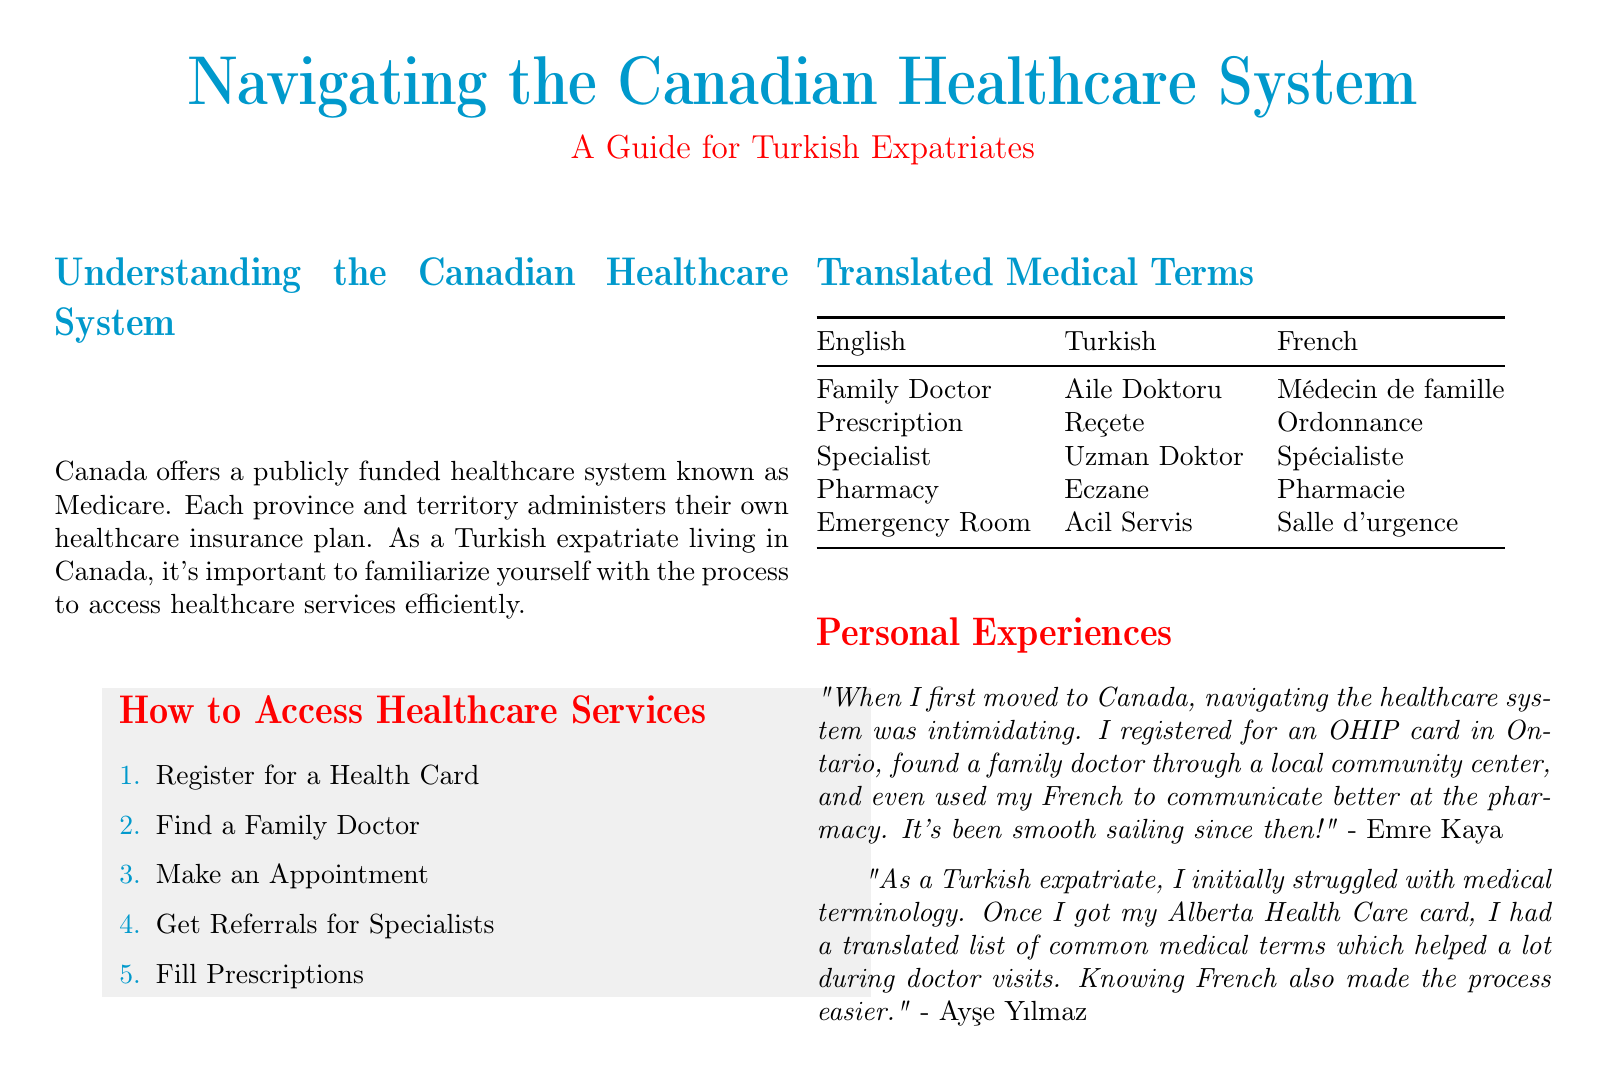What is the title of the document? The title of the document is prominently displayed at the top of the first page.
Answer: Navigating the Canadian Healthcare System Who is the guide primarily intended for? The introduction clearly states the target audience for the guide.
Answer: Turkish Expatriates What is the first step to access healthcare services? The steps to access healthcare are listed in a numbered format, with the first step highlighted.
Answer: Register for a Health Card How many translated medical terms are provided in the table? The table lists a total of five medical terms in three languages.
Answer: Five Who provided the personal anecdote about navigating the healthcare system in Ontario? The personal experiences section contains anecdotes attributed to specific individuals.
Answer: Emre Kaya What color is used for the headings? The document uses a consistent color for section headings throughout.
Answer: Turkish blue In which province was the OHIP card registered? The personal experiences section mentions the specific province related to the OHIP card.
Answer: Ontario What type of card is mentioned in relation to Alberta? The anecdote includes a reference to a specific healthcare card for residents of Alberta.
Answer: Alberta Health Care card What are the two main colors used in the design? The document includes color elements that stand out and are used throughout.
Answer: Turkish blue and Canadian red 